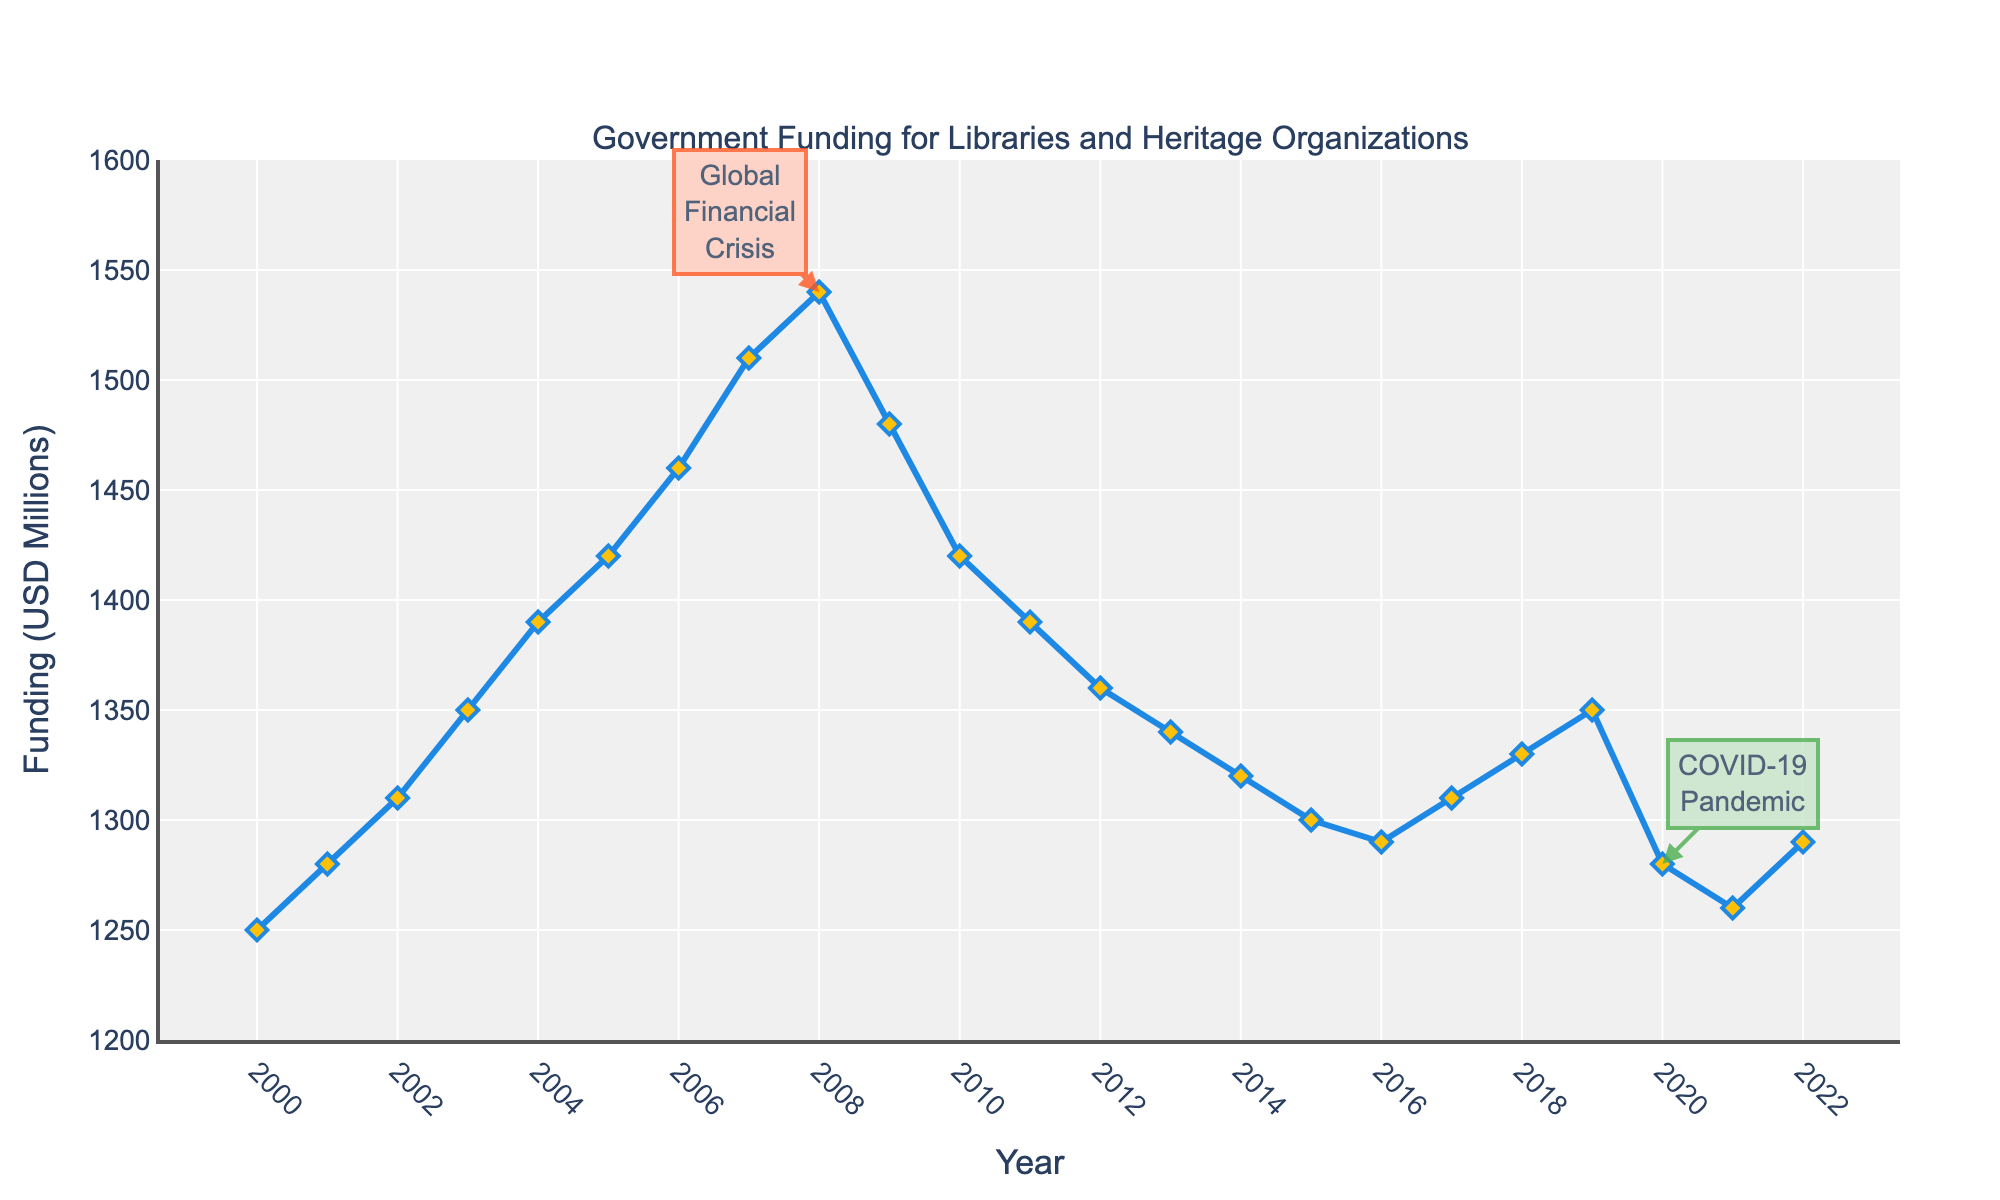What is the overall trend of government funding from 2000 to 2022? Observe the line chart from 2000 to 2022. Initially, there's a rising trend from 2000 to 2008, peaking in 2008. After 2008, there's a noticeable decline up to around 2014, then a modest recovery follows but ends at a lower point in 2022 compared to 2008.
Answer: Increasing trend until 2008, then generally decreasing In which years did government funding peak and bottom out? The highest point on the chart is in 2008, where the government funding is $1540 million. The lowest point after the peak is in 2021, where the funding is $1260 million.
Answer: 2008 and 2021 How did the Global Financial Crisis appear to affect government funding in subsequent years? The funding peaked in 2008, followed by a decline starting in 2009, coinciding with the crisis. The trend continues downwards noticeably from 2009 to 2011.
Answer: Decreased sharply after 2008 What's the difference in government funding between 2008 and 2021? Funding in 2008 is $1540 million, and in 2021 it is $1260 million. Calculating the difference: 1540 - 1260 = 280.
Answer: $280 million Which two years have the closest funding levels despite being separated by more than a decade? Compare levels across the span. In 2000 funding is $1250 million and in 2022 it is $1290 million, a difference of $40 million, which is smaller than other differences over a long span.
Answer: 2000 and 2022 with a $40 million difference How does the funding level in 2020 compare to that in 2019? From the chart, in 2019 funding is $1350 million and in 2020 it is $1280 million. Thus, 2020 has less funding than 2019.
Answer: Lower in 2020 What is the average government funding level from 2010 to 2022? Sum the funding levels from 2010 to 2022 and divide by the number of years. Sum: 1420+1390+1360+1340+1320+1300+1290+1310+1330+1350+1280+1260+1290 = 16940. Number of years: 2022-2010+1 = 13. Average = 16940 / 13 ≈ 1303.
Answer: Approximately $1303 million What visual features highlight critical events like the Global Financial Crisis and the COVID-19 pandemic? The chart uses annotations with arrows, text labels, and colored backgrounds to highlight 2008 (Global Financial Crisis) and 2020 (COVID-19 pandemic).
Answer: Annotations with arrows and text Did government funding ever return to 2008 levels after the Global Financial Crisis? Observe the funding levels after 2008 to 2022. No subsequent year reaches $1540 million (the 2008 level).
Answer: No What is the longest consecutive decline in funding levels observed on the chart? Identify stretches where funding continuously decreases. From 2008 ($1540 million) to 2012 ($1360 million) is a continuous decline of 4 years.
Answer: 4 years (2008 to 2012) 